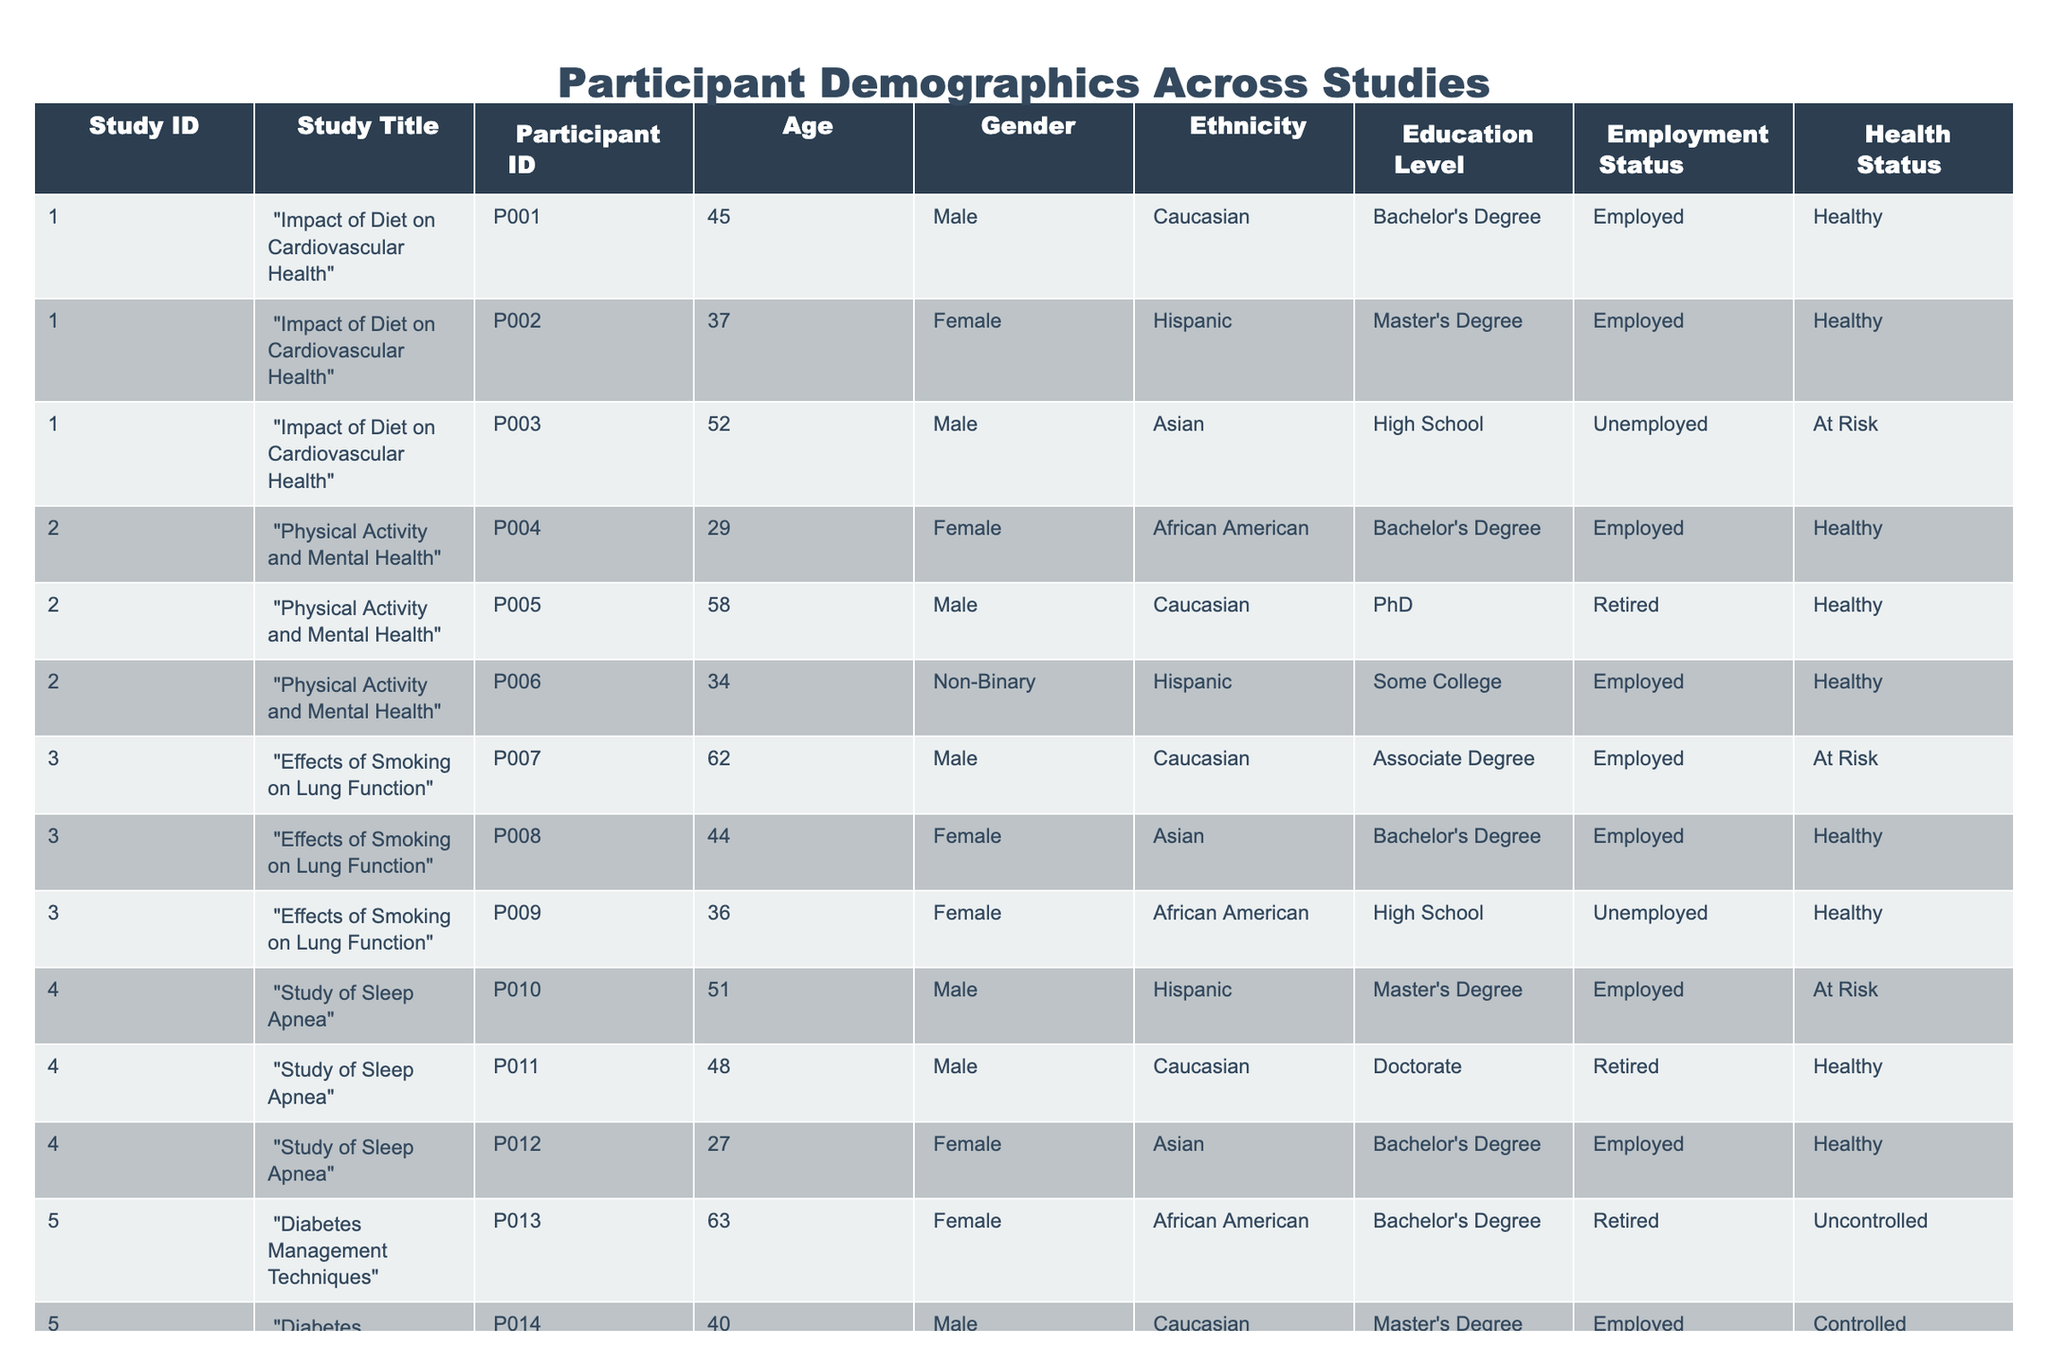What is the age of the youngest participant across all studies? The youngest participant is P012, who is 27 years old. By scanning through the Age column, P012 has the lowest value compared to others.
Answer: 27 How many participants are employed across all studies? By looking at the Employment Status column, there are 6 participants that are marked as Employed: P001, P002, P004, P006, P010, P014, and P015. Counting these gives a total of 6 employed participants.
Answer: 6 Is there a participant with a Doctorate degree? Yes, participant P011 has a Doctorate according to the Education Level column. Checking all entries, only P011 has this qualification.
Answer: Yes What percentage of participants identify as Female? There are 5 female participants (P002, P004, P008, P012, P013) out of 15 total participants. The percentage can be calculated as (5/15) * 100%, which equals 33.33%.
Answer: 33.33% Which study has the most participants? Study ID 1 ("Impact of Diet on Cardiovascular Health") has 3 participants (P001, P002, P003). Upon reviewing each study, it appears that all others have fewer participants (2 or 3).
Answer: Study ID 1 What is the average age of participants in Study ID 2? The ages of participants in Study ID 2 are: P004 (29), P005 (58), and P006 (34). The average is calculated as (29 + 58 + 34) / 3 = 121 / 3 = 40.33.
Answer: 40.33 How many participants are classified as "At Risk" in terms of health status? The participants classified as "At Risk" are P003, P007, P010, and P013. Counting them gives us a total of 4 participants.
Answer: 4 Are there more Non-Binary participants than retired participants? There are 2 Non-Binary participants (P006, P015) and 4 retired participants (P005, P011, P013), which means Non-Binary participants are fewer. Comparing these counts shows that there are more retired participants.
Answer: No What is the median age of all participants? The ages of participants sorted in ascending order are: 27, 29, 32, 34, 36, 37, 40, 44, 45, 48, 51, 52, 58, 62, 63. Since there are 15 participants, the median is the middle one, which is the 8th value: 44.
Answer: 44 